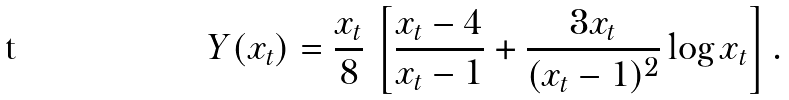Convert formula to latex. <formula><loc_0><loc_0><loc_500><loc_500>Y ( x _ { t } ) = \frac { x _ { t } } { 8 } \, \left [ \frac { x _ { t } - 4 } { x _ { t } - 1 } + \frac { 3 x _ { t } } { ( x _ { t } - 1 ) ^ { 2 } } \log x _ { t } \right ] .</formula> 